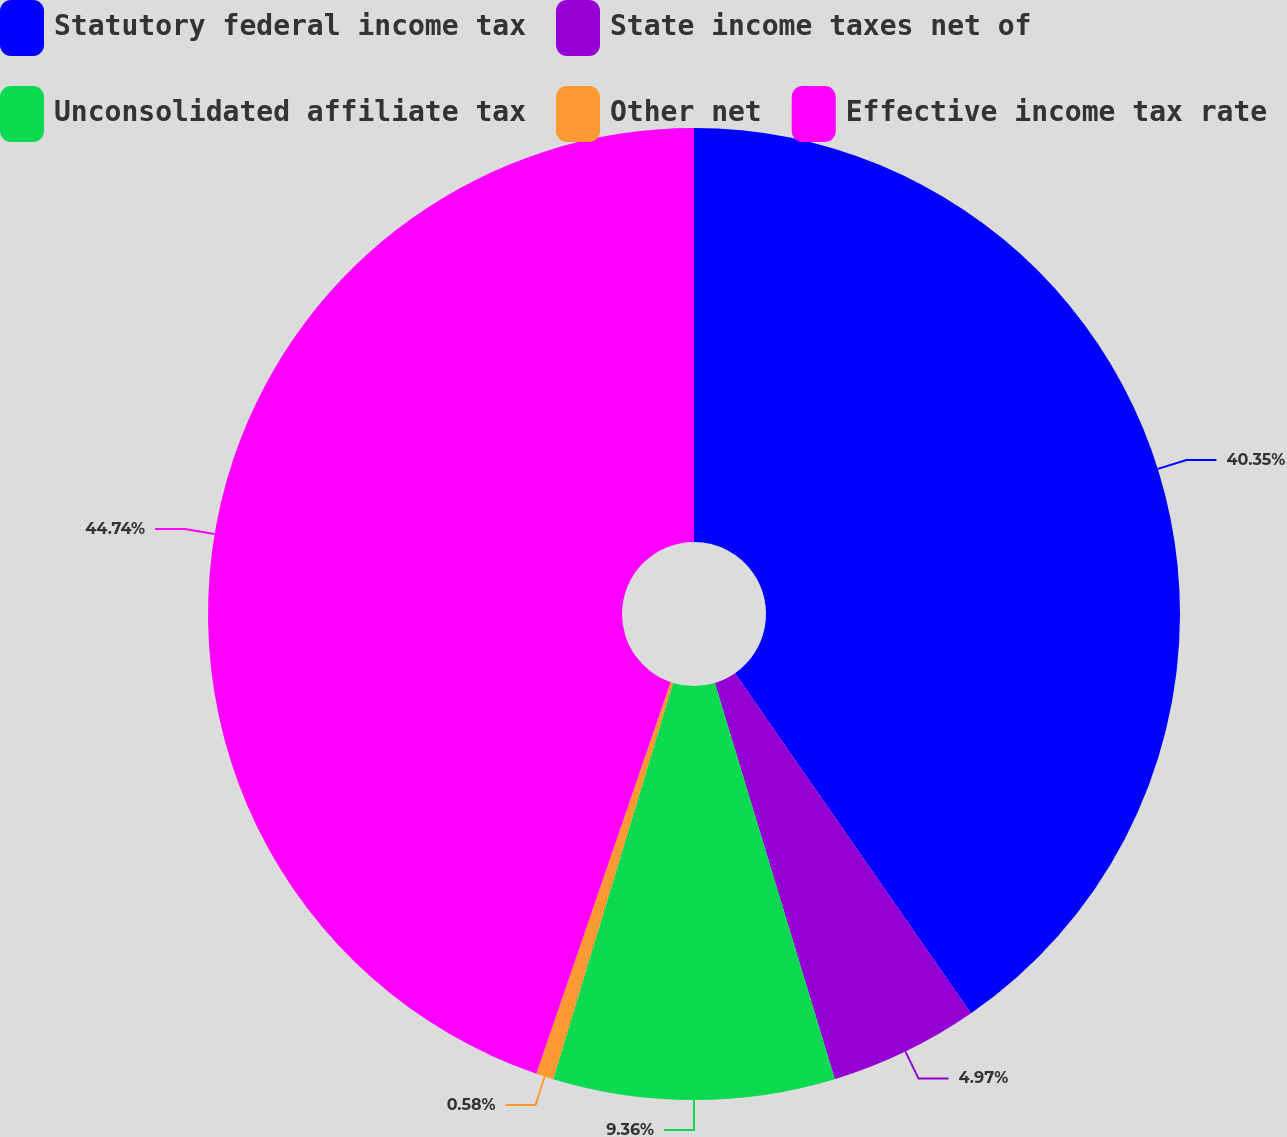<chart> <loc_0><loc_0><loc_500><loc_500><pie_chart><fcel>Statutory federal income tax<fcel>State income taxes net of<fcel>Unconsolidated affiliate tax<fcel>Other net<fcel>Effective income tax rate<nl><fcel>40.35%<fcel>4.97%<fcel>9.36%<fcel>0.58%<fcel>44.74%<nl></chart> 